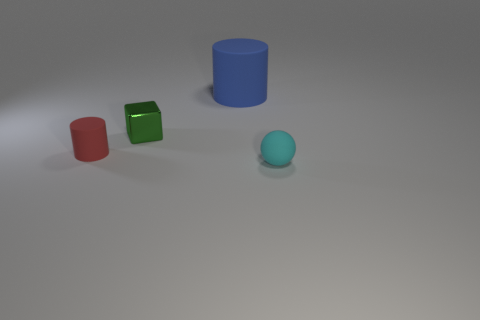Add 3 matte objects. How many objects exist? 7 Subtract all cubes. How many objects are left? 3 Add 1 tiny metal things. How many tiny metal things are left? 2 Add 1 small blue rubber objects. How many small blue rubber objects exist? 1 Subtract 0 brown cubes. How many objects are left? 4 Subtract all rubber cylinders. Subtract all tiny matte balls. How many objects are left? 1 